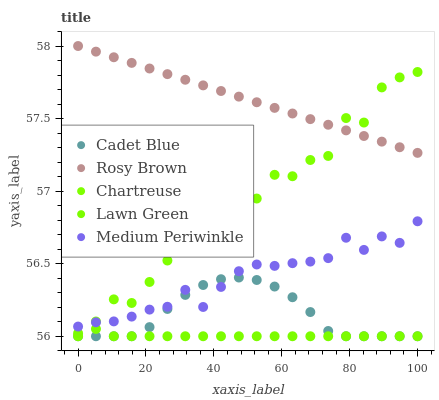Does Lawn Green have the minimum area under the curve?
Answer yes or no. Yes. Does Rosy Brown have the maximum area under the curve?
Answer yes or no. Yes. Does Cadet Blue have the minimum area under the curve?
Answer yes or no. No. Does Cadet Blue have the maximum area under the curve?
Answer yes or no. No. Is Rosy Brown the smoothest?
Answer yes or no. Yes. Is Chartreuse the roughest?
Answer yes or no. Yes. Is Cadet Blue the smoothest?
Answer yes or no. No. Is Cadet Blue the roughest?
Answer yes or no. No. Does Lawn Green have the lowest value?
Answer yes or no. Yes. Does Rosy Brown have the lowest value?
Answer yes or no. No. Does Rosy Brown have the highest value?
Answer yes or no. Yes. Does Cadet Blue have the highest value?
Answer yes or no. No. Is Medium Periwinkle less than Rosy Brown?
Answer yes or no. Yes. Is Medium Periwinkle greater than Lawn Green?
Answer yes or no. Yes. Does Lawn Green intersect Cadet Blue?
Answer yes or no. Yes. Is Lawn Green less than Cadet Blue?
Answer yes or no. No. Is Lawn Green greater than Cadet Blue?
Answer yes or no. No. Does Medium Periwinkle intersect Rosy Brown?
Answer yes or no. No. 